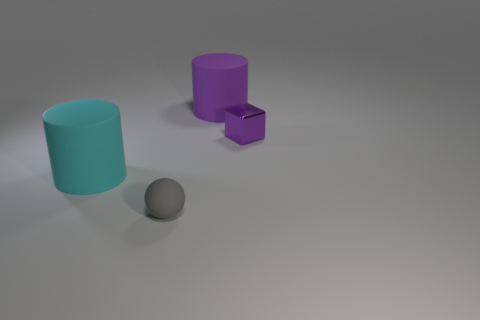Add 1 tiny gray matte balls. How many objects exist? 5 Subtract all brown shiny blocks. Subtract all metallic objects. How many objects are left? 3 Add 3 purple blocks. How many purple blocks are left? 4 Add 4 purple shiny objects. How many purple shiny objects exist? 5 Subtract 1 purple blocks. How many objects are left? 3 